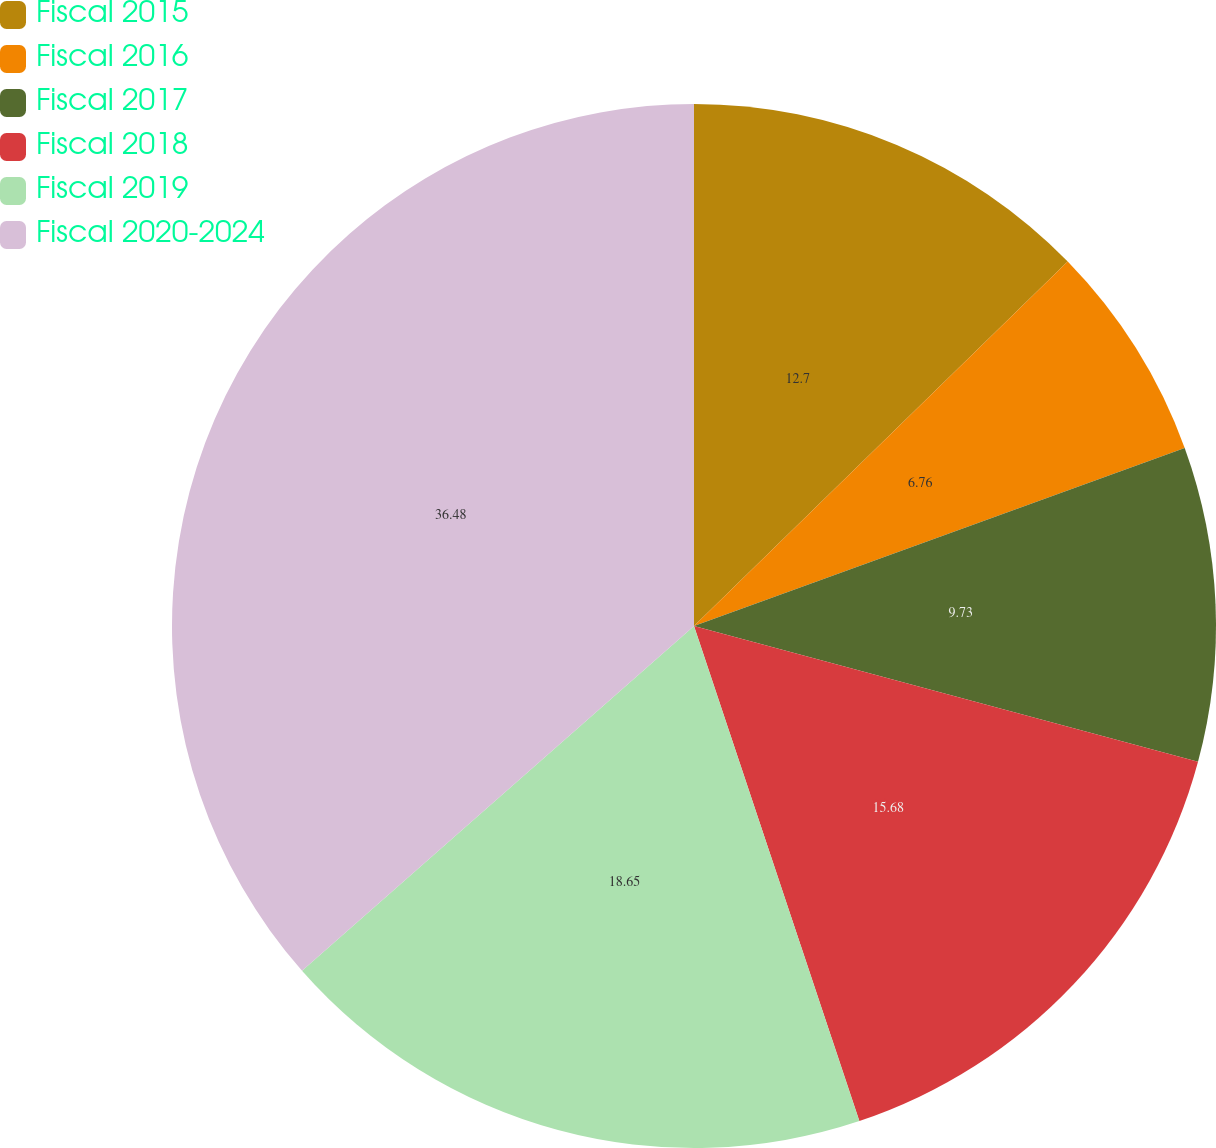Convert chart to OTSL. <chart><loc_0><loc_0><loc_500><loc_500><pie_chart><fcel>Fiscal 2015<fcel>Fiscal 2016<fcel>Fiscal 2017<fcel>Fiscal 2018<fcel>Fiscal 2019<fcel>Fiscal 2020-2024<nl><fcel>12.7%<fcel>6.76%<fcel>9.73%<fcel>15.68%<fcel>18.65%<fcel>36.48%<nl></chart> 